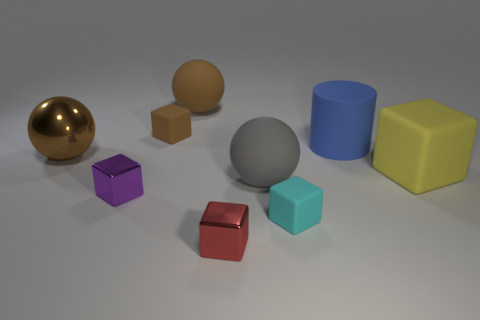Subtract all yellow cylinders. Subtract all gray spheres. How many cylinders are left? 1 Subtract all yellow cubes. How many yellow spheres are left? 0 Add 3 blues. How many tiny reds exist? 0 Subtract all gray matte balls. Subtract all cylinders. How many objects are left? 7 Add 9 large blue things. How many large blue things are left? 10 Add 2 large blue matte cylinders. How many large blue matte cylinders exist? 3 Add 1 green spheres. How many objects exist? 10 Subtract all gray spheres. How many spheres are left? 2 Subtract all metallic blocks. How many blocks are left? 3 Subtract 0 yellow cylinders. How many objects are left? 9 